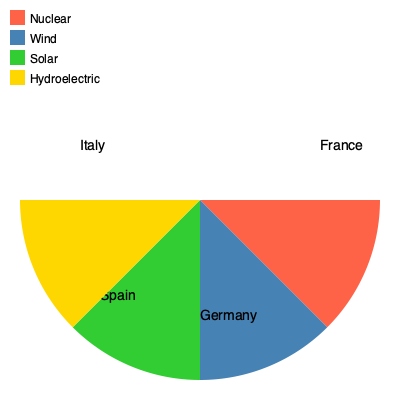The pie chart shows the distribution of renewable energy sources in four European countries. Which country has the highest percentage of nuclear energy in its renewable energy mix, and what percentage does it represent? To answer this question, we need to analyze the pie chart and follow these steps:

1. Identify the countries represented in the pie chart:
   - France
   - Germany
   - Spain
   - Italy

2. Recognize that each color represents a different renewable energy source:
   - Red (FF6347): Nuclear
   - Blue (4682B4): Wind
   - Green (32CD32): Solar
   - Yellow (FFD700): Hydroelectric

3. Compare the size of the red sections (nuclear energy) for each country:
   - France has the largest red section
   - Germany, Spain, and Italy have no visible red sections

4. Estimate the percentage of the red section for France:
   - The red section covers approximately 90° of the circle
   - A full circle is 360°

5. Calculate the percentage:
   $\frac{90°}{360°} \times 100\% = 25\%$

Therefore, France has the highest percentage of nuclear energy in its renewable energy mix, representing approximately 25% of its total renewable energy production.
Answer: France, 25% 